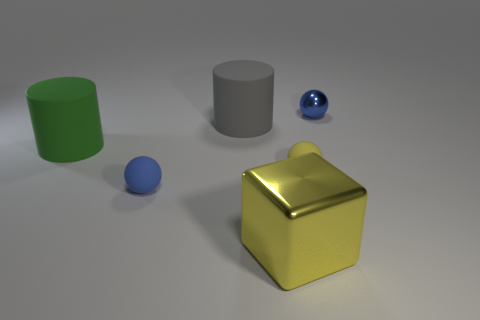Add 2 small blue matte things. How many objects exist? 8 Subtract all cylinders. How many objects are left? 4 Subtract 0 cyan blocks. How many objects are left? 6 Subtract all small yellow rubber objects. Subtract all blue objects. How many objects are left? 3 Add 2 blue metal things. How many blue metal things are left? 3 Add 5 tiny yellow balls. How many tiny yellow balls exist? 6 